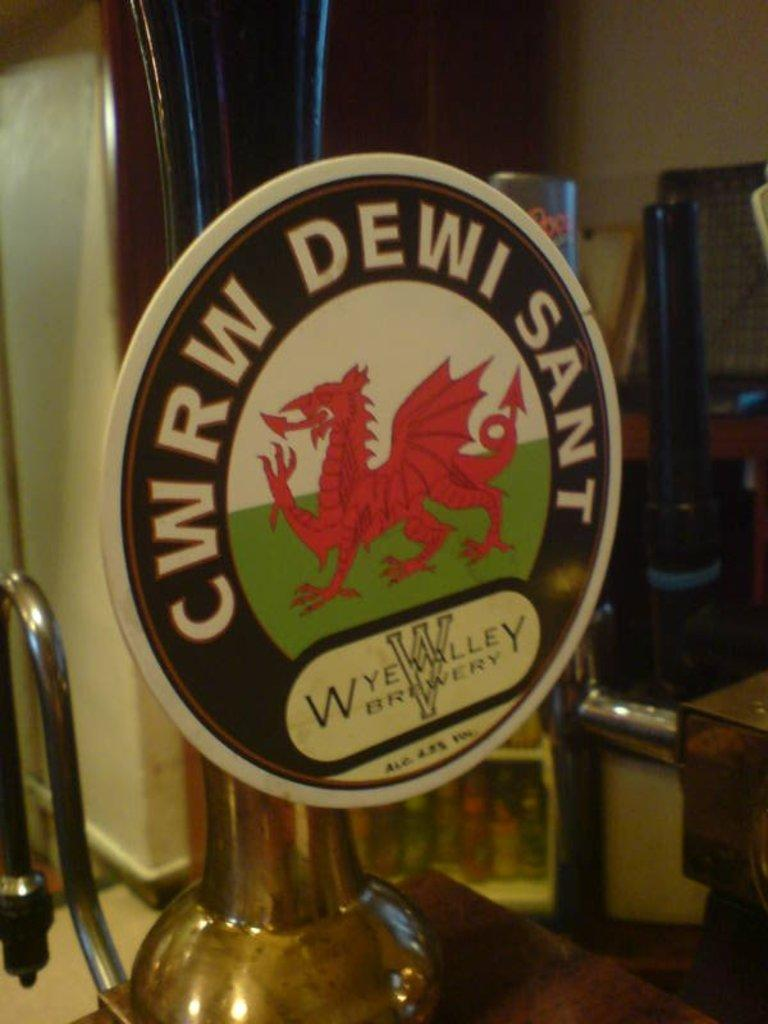<image>
Describe the image concisely. A label for CRWR Dewi Sant sits on top of a tap 